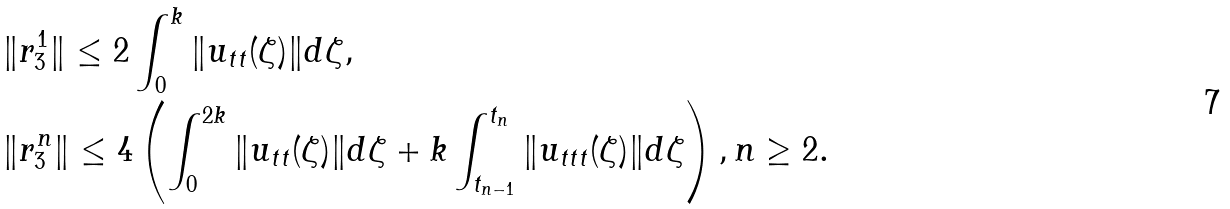<formula> <loc_0><loc_0><loc_500><loc_500>& \| r _ { 3 } ^ { 1 } \| \leq 2 \int _ { 0 } ^ { k } \| u _ { t t } ( \zeta ) \| d \zeta , \\ & \| r _ { 3 } ^ { n } \| \leq 4 \left ( \int _ { 0 } ^ { 2 k } \| u _ { t t } ( \zeta ) \| d \zeta + k \int _ { t _ { n - 1 } } ^ { t _ { n } } \| u _ { t t t } ( \zeta ) \| d \zeta \right ) , n \geq 2 .</formula> 